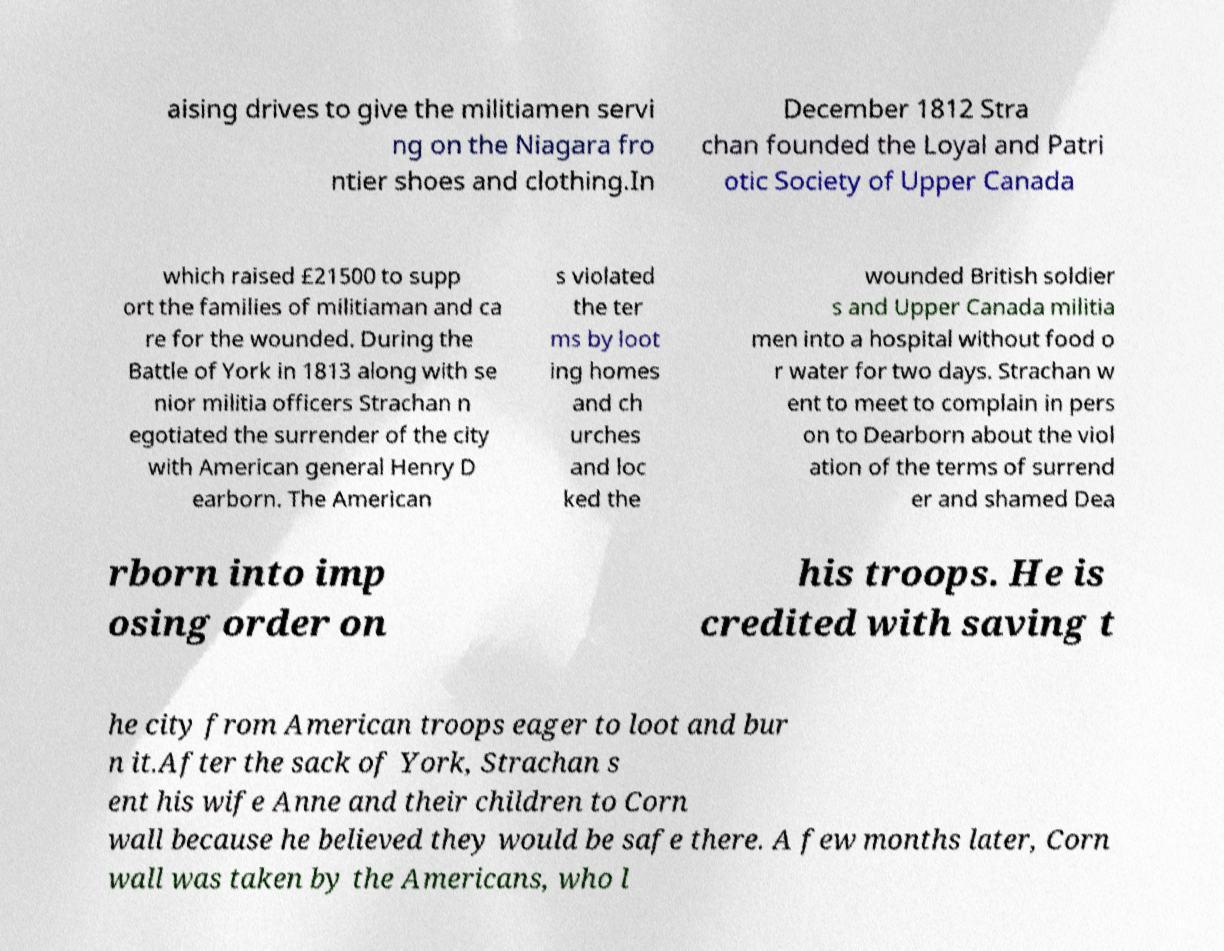Could you assist in decoding the text presented in this image and type it out clearly? aising drives to give the militiamen servi ng on the Niagara fro ntier shoes and clothing.In December 1812 Stra chan founded the Loyal and Patri otic Society of Upper Canada which raised £21500 to supp ort the families of militiaman and ca re for the wounded. During the Battle of York in 1813 along with se nior militia officers Strachan n egotiated the surrender of the city with American general Henry D earborn. The American s violated the ter ms by loot ing homes and ch urches and loc ked the wounded British soldier s and Upper Canada militia men into a hospital without food o r water for two days. Strachan w ent to meet to complain in pers on to Dearborn about the viol ation of the terms of surrend er and shamed Dea rborn into imp osing order on his troops. He is credited with saving t he city from American troops eager to loot and bur n it.After the sack of York, Strachan s ent his wife Anne and their children to Corn wall because he believed they would be safe there. A few months later, Corn wall was taken by the Americans, who l 